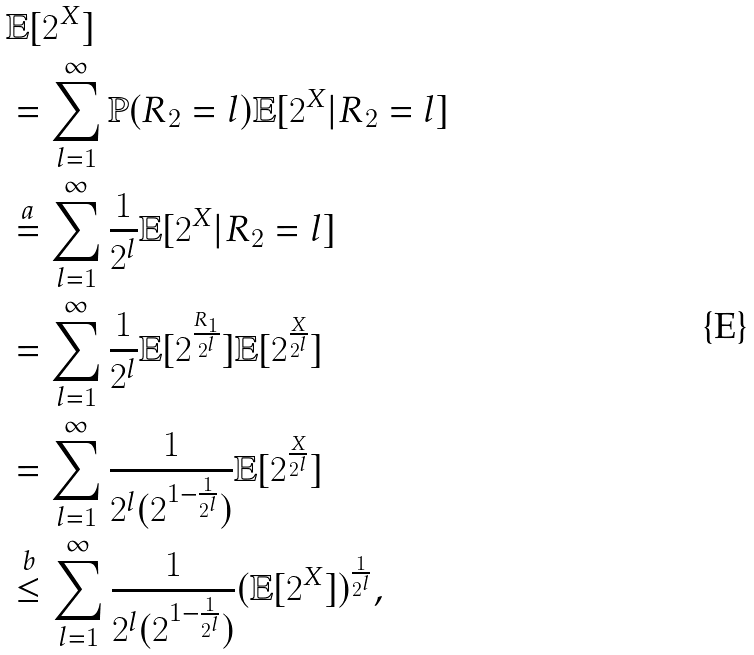<formula> <loc_0><loc_0><loc_500><loc_500>& \mathbb { E } [ 2 ^ { X } ] \\ & = \sum _ { l = 1 } ^ { \infty } \mathbb { P } ( R _ { 2 } = l ) \mathbb { E } [ 2 ^ { X } | R _ { 2 } = l ] \\ & \stackrel { a } { = } \sum _ { l = 1 } ^ { \infty } \frac { 1 } { 2 ^ { l } } \mathbb { E } [ 2 ^ { X } | R _ { 2 } = l ] \\ & = \sum _ { l = 1 } ^ { \infty } \frac { 1 } { 2 ^ { l } } \mathbb { E } [ 2 ^ { \frac { R _ { 1 } } { 2 ^ { l } } } ] \mathbb { E } [ 2 ^ { \frac { X } { 2 ^ { l } } } ] \\ & = \sum _ { l = 1 } ^ { \infty } \frac { 1 } { 2 ^ { l } ( 2 ^ { 1 - \frac { 1 } { 2 ^ { l } } } ) } \mathbb { E } [ 2 ^ { \frac { X } { 2 ^ { l } } } ] \\ & \stackrel { b } { \leq } \sum _ { l = 1 } ^ { \infty } \frac { 1 } { 2 ^ { l } ( 2 ^ { 1 - \frac { 1 } { 2 ^ { l } } } ) } ( \mathbb { E } [ 2 ^ { X } ] ) ^ { \frac { 1 } { 2 ^ { l } } } , \\</formula> 